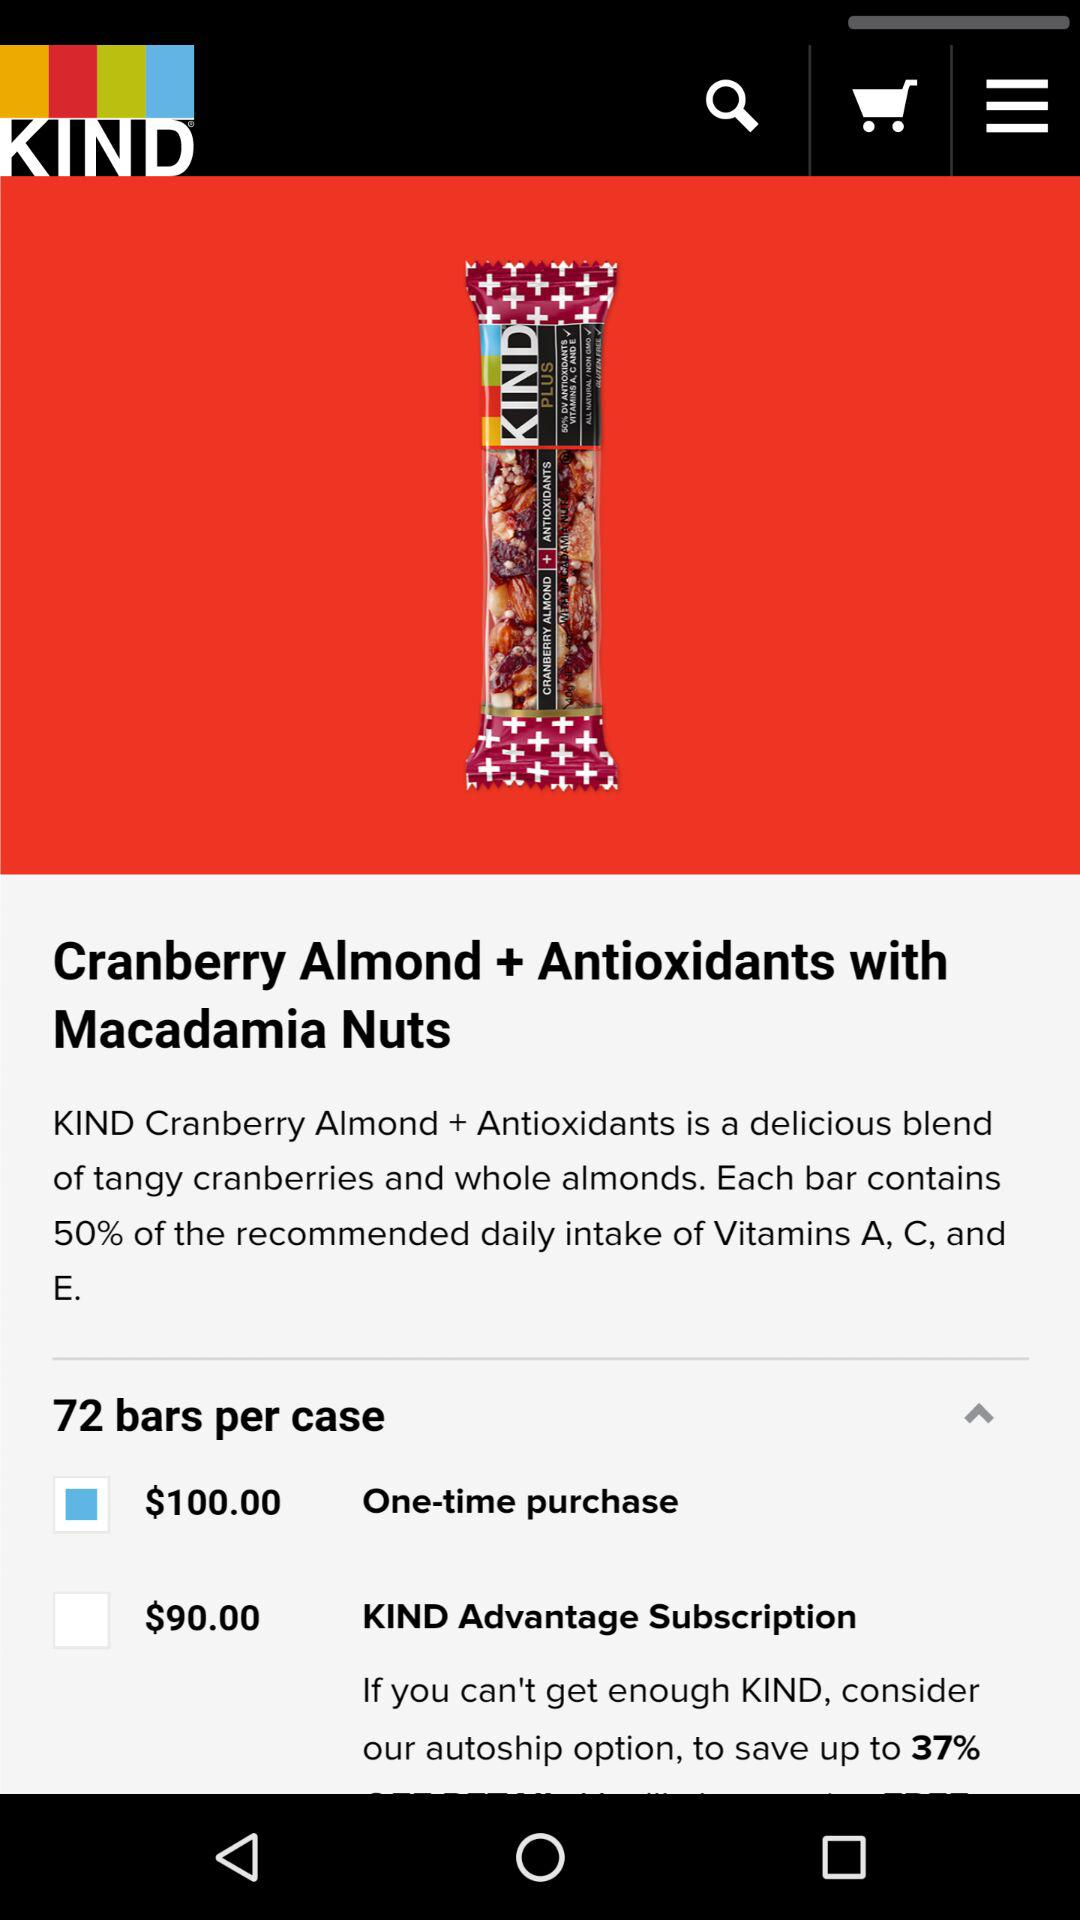How many bars are in a case?
Answer the question using a single word or phrase. 72 